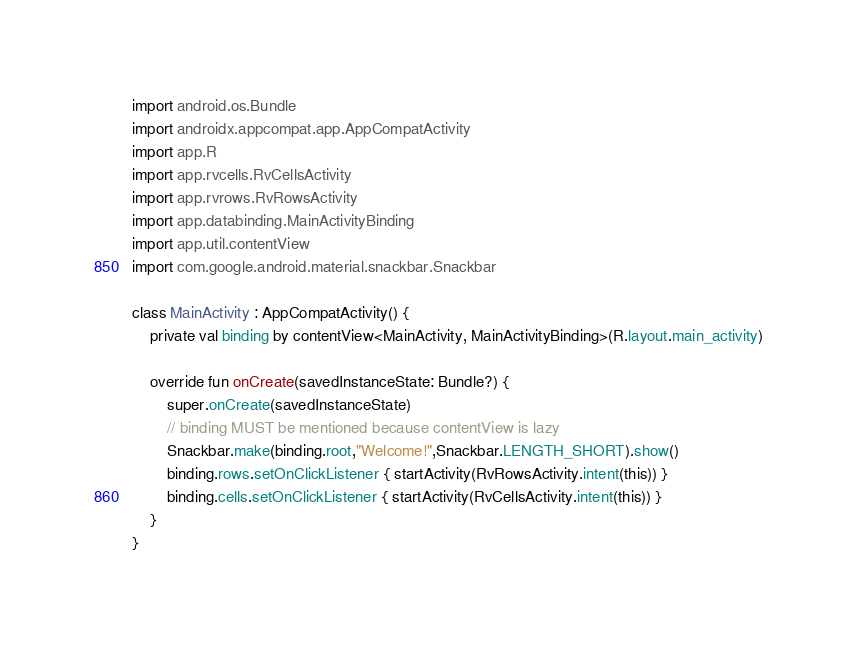<code> <loc_0><loc_0><loc_500><loc_500><_Kotlin_>import android.os.Bundle
import androidx.appcompat.app.AppCompatActivity
import app.R
import app.rvcells.RvCellsActivity
import app.rvrows.RvRowsActivity
import app.databinding.MainActivityBinding
import app.util.contentView
import com.google.android.material.snackbar.Snackbar

class MainActivity : AppCompatActivity() {
    private val binding by contentView<MainActivity, MainActivityBinding>(R.layout.main_activity)

    override fun onCreate(savedInstanceState: Bundle?) {
        super.onCreate(savedInstanceState)
        // binding MUST be mentioned because contentView is lazy
        Snackbar.make(binding.root,"Welcome!",Snackbar.LENGTH_SHORT).show()
        binding.rows.setOnClickListener { startActivity(RvRowsActivity.intent(this)) }
        binding.cells.setOnClickListener { startActivity(RvCellsActivity.intent(this)) }
    }
}
</code> 